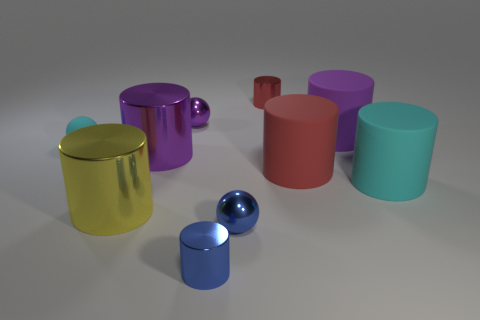How many other objects are there of the same shape as the large red rubber thing?
Provide a short and direct response. 6. What material is the cylinder that is both behind the small cyan matte object and to the right of the red metallic thing?
Provide a short and direct response. Rubber. What number of objects are purple matte cylinders or tiny brown rubber spheres?
Keep it short and to the point. 1. Are there more tiny cyan rubber balls than gray matte things?
Your answer should be compact. Yes. There is a metallic cylinder that is behind the big metallic cylinder to the right of the large yellow cylinder; what size is it?
Offer a very short reply. Small. The other big metallic object that is the same shape as the yellow thing is what color?
Your answer should be compact. Purple. The purple metal sphere has what size?
Provide a short and direct response. Small. How many blocks are big red objects or purple objects?
Offer a terse response. 0. There is another blue thing that is the same shape as the tiny rubber thing; what size is it?
Provide a short and direct response. Small. What number of cyan balls are there?
Your answer should be compact. 1. 